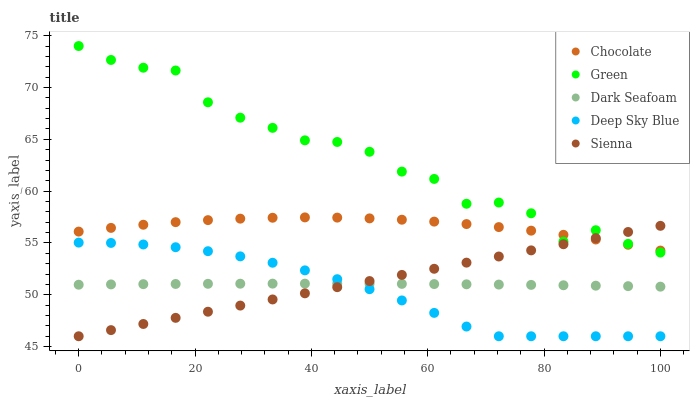Does Deep Sky Blue have the minimum area under the curve?
Answer yes or no. Yes. Does Green have the maximum area under the curve?
Answer yes or no. Yes. Does Dark Seafoam have the minimum area under the curve?
Answer yes or no. No. Does Dark Seafoam have the maximum area under the curve?
Answer yes or no. No. Is Sienna the smoothest?
Answer yes or no. Yes. Is Green the roughest?
Answer yes or no. Yes. Is Dark Seafoam the smoothest?
Answer yes or no. No. Is Dark Seafoam the roughest?
Answer yes or no. No. Does Sienna have the lowest value?
Answer yes or no. Yes. Does Dark Seafoam have the lowest value?
Answer yes or no. No. Does Green have the highest value?
Answer yes or no. Yes. Does Dark Seafoam have the highest value?
Answer yes or no. No. Is Deep Sky Blue less than Chocolate?
Answer yes or no. Yes. Is Chocolate greater than Dark Seafoam?
Answer yes or no. Yes. Does Sienna intersect Deep Sky Blue?
Answer yes or no. Yes. Is Sienna less than Deep Sky Blue?
Answer yes or no. No. Is Sienna greater than Deep Sky Blue?
Answer yes or no. No. Does Deep Sky Blue intersect Chocolate?
Answer yes or no. No. 